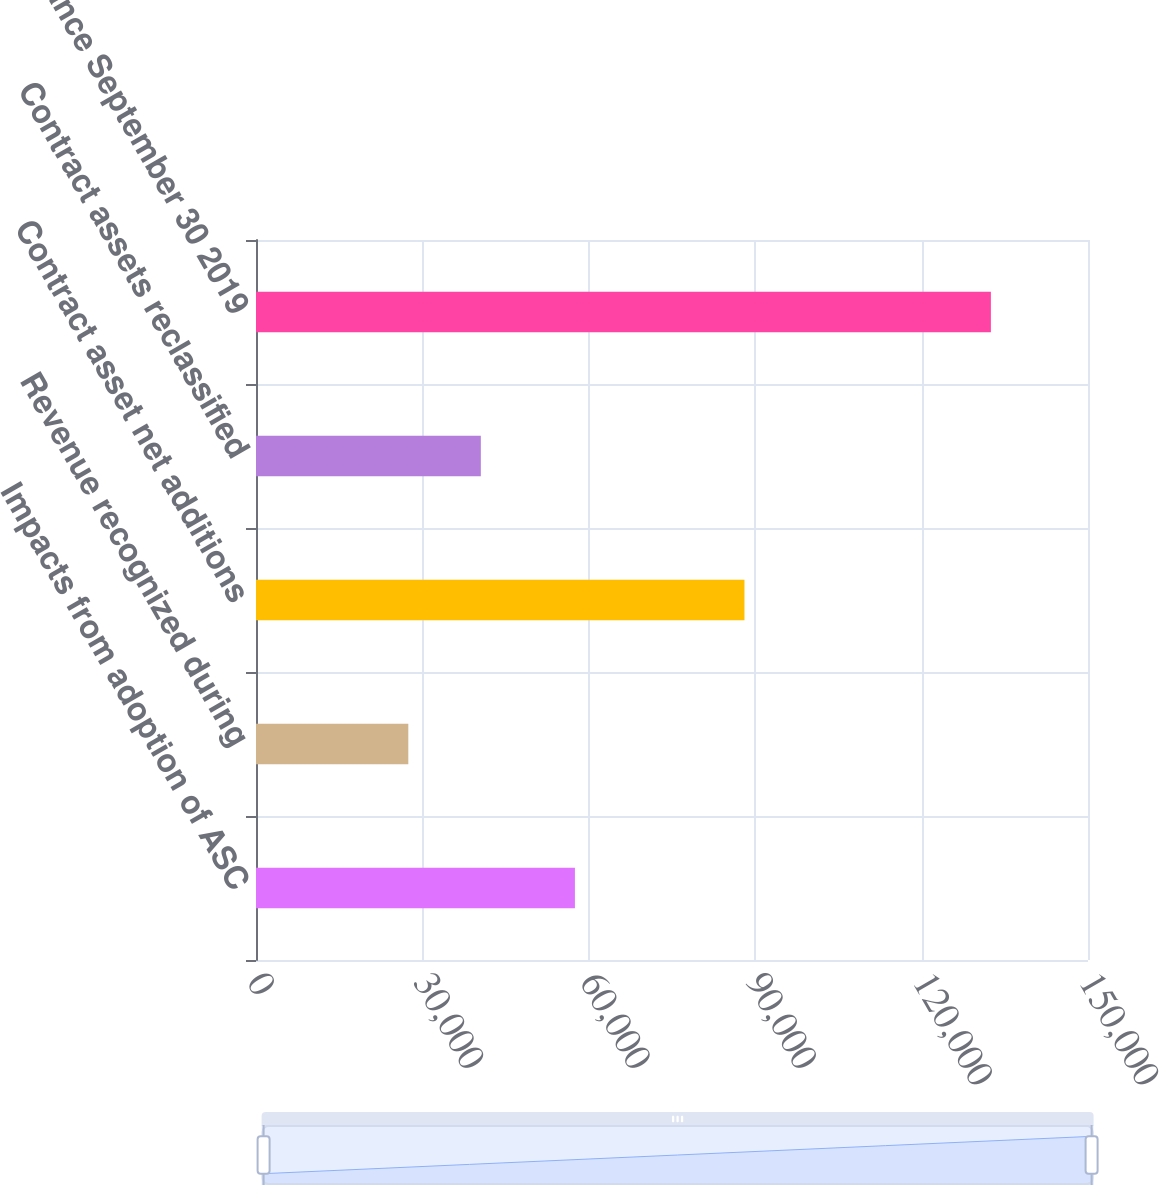<chart> <loc_0><loc_0><loc_500><loc_500><bar_chart><fcel>Impacts from adoption of ASC<fcel>Revenue recognized during<fcel>Contract asset net additions<fcel>Contract assets reclassified<fcel>Balance September 30 2019<nl><fcel>57499<fcel>27459<fcel>88068<fcel>40534<fcel>132492<nl></chart> 